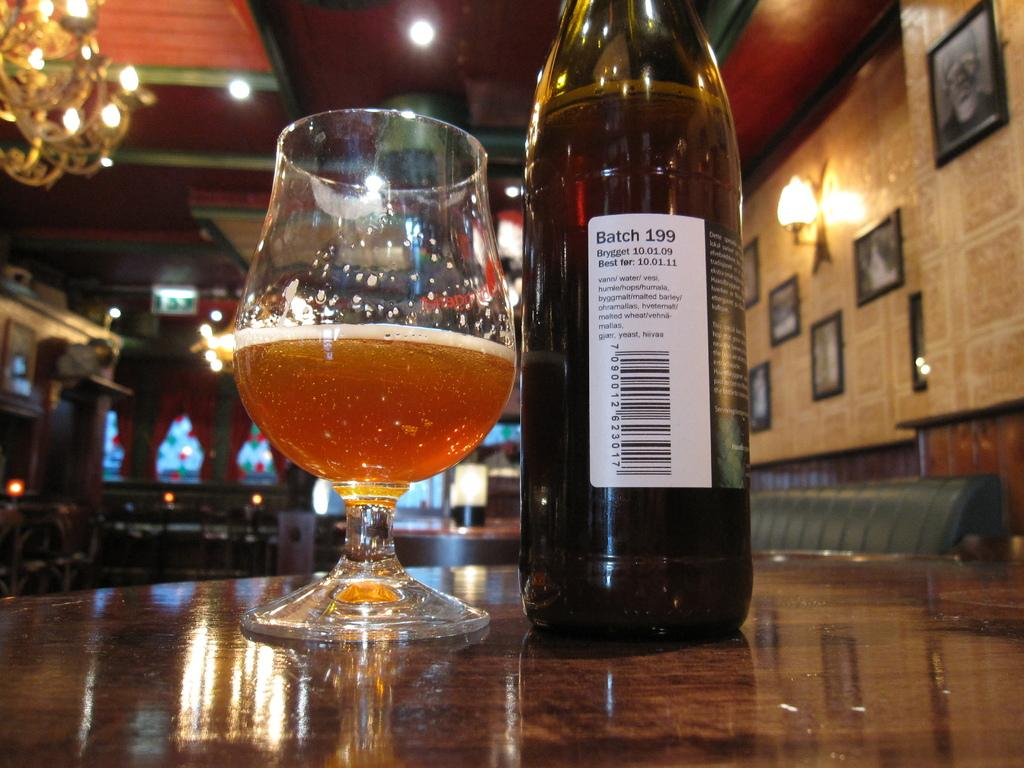What is in the glass that is visible in the image? There is a glass of wine in the image. What else related to wine can be seen in the image? There is a wine bottle with a label in the image. Where are the glass and the bottle located? Both the glass and the bottle are on a table. What can be seen on the wall in the background of the image? There are frames attached to the wall in the background of the image. What type of lighting is visible in the background of the image? There are lights visible in the background of the image, including a chandelier. What type of furniture is visible in the background of the image? There is a couch in the background of the image. What type of toys can be seen on the table with the glass and wine bottle? There are no toys present on the table with the glass and wine bottle in the image. 